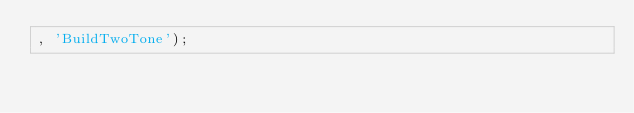<code> <loc_0><loc_0><loc_500><loc_500><_JavaScript_>, 'BuildTwoTone');
</code> 